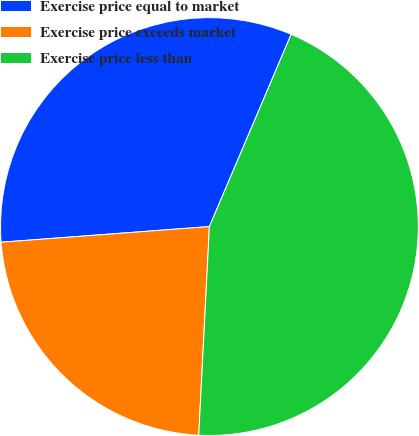Convert chart to OTSL. <chart><loc_0><loc_0><loc_500><loc_500><pie_chart><fcel>Exercise price equal to market<fcel>Exercise price exceeds market<fcel>Exercise price less than<nl><fcel>32.59%<fcel>22.99%<fcel>44.41%<nl></chart> 